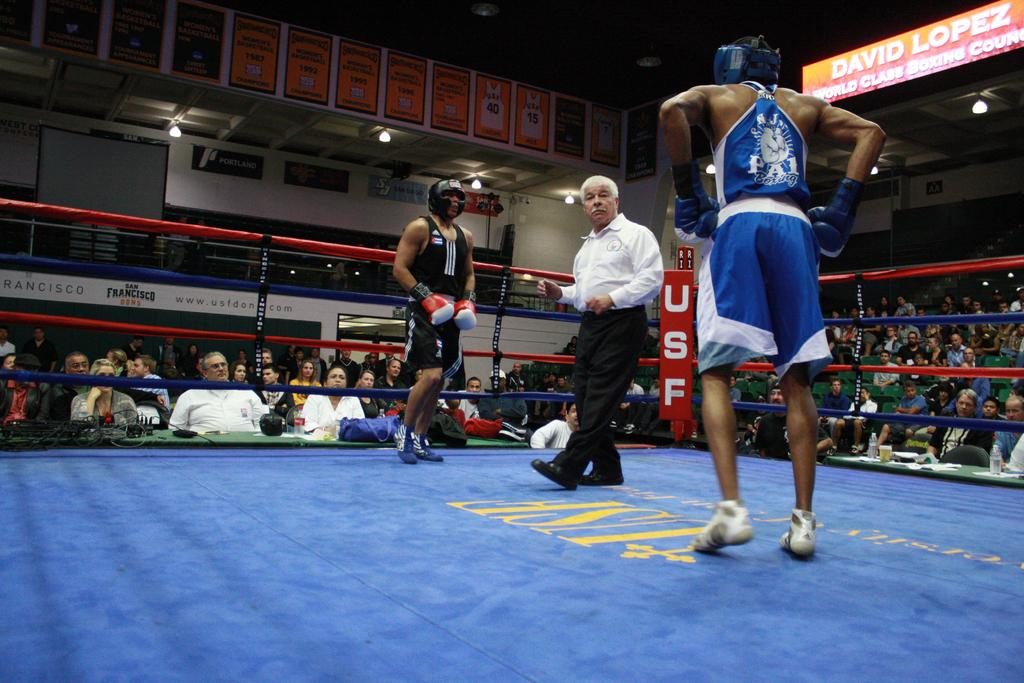<image>
Render a clear and concise summary of the photo. A sign above the seating area shows one of the competitors is David Lopez. 